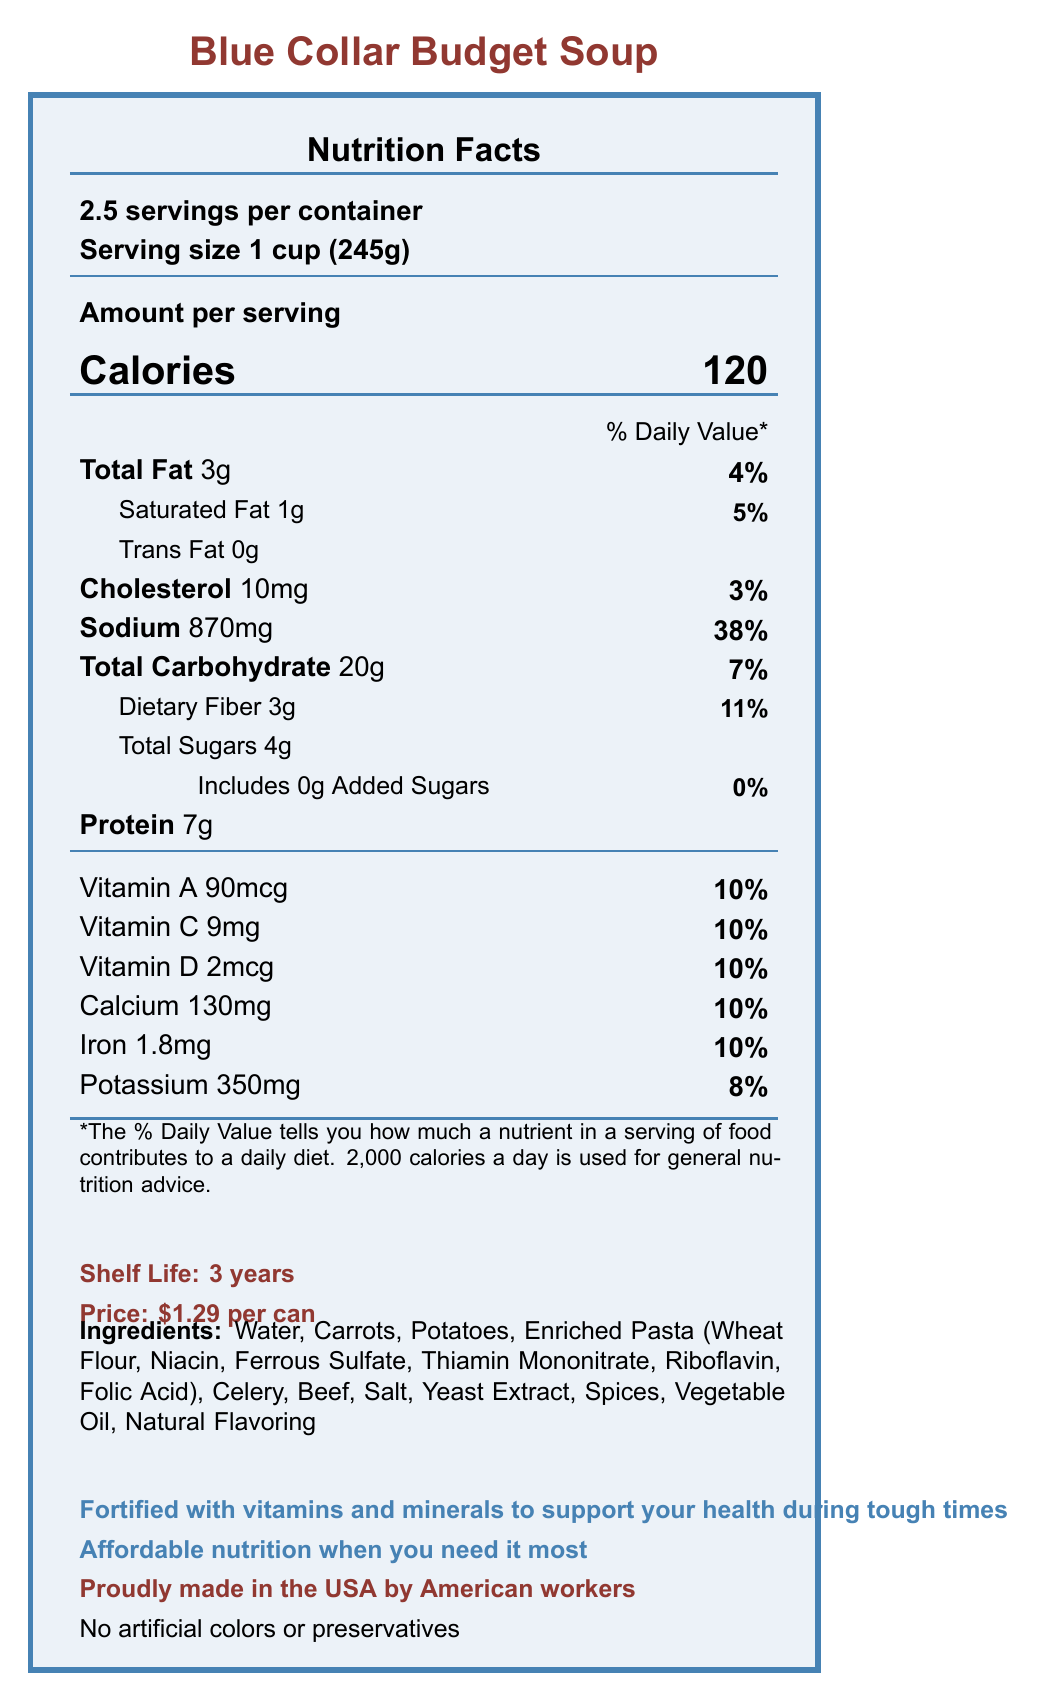what is the serving size of Blue Collar Budget Soup? The serving size is clearly stated as "1 cup (245g)" on the Nutrition Facts Label.
Answer: 1 cup (245g) how many servings are in one container? The document specifies that there are "2.5 servings per container."
Answer: 2.5 servings how many calories are there per serving? It is mentioned that each serving has "120 calories."
Answer: 120 what is the total fat percentage of the daily value per serving? The total fat amount is 3g, which is 4% of the daily value.
Answer: 4% what is the sodium content per serving? The sodium content is listed as "870mg" per serving.
Answer: 870mg how many grams of protein are there in one serving? The document states that there are "7g" of protein per serving.
Answer: 7g how much vitamin A is there per serving? The amount of vitamin A per serving is 90mcg, which is 10% of the daily value.
Answer: 90mcg (10% Daily Value) which ingredient is listed first in the ingredients section? The ingredients list starts with "Water."
Answer: Water what is the shelf life of the product? The shelf life is specified to be "3 years."
Answer: 3 years how much does one can cost? The price is mentioned as "$1.29 per can."
Answer: $1.29 per can how much saturated fat does each serving of soup contain? Each serving contains "1g" of saturated fat.
Answer: 1g what percentage of the daily value of calcium is in one serving? The calcium content per serving is 130mg, which is 10% of the daily value.
Answer: 10% does the soup contain any artificial colors or preservatives? The document states, "No artificial colors or preservatives."
Answer: No which vitamin amount is higher per serving, Vitamin C or Iron? Both Vitamin C and Iron are at 10% Daily Value, but the iron amount in mg is higher.
Answer: Iron how is the protein content compared to the dietary fiber content? A. Higher B. Lower C. Equal The protein content per serving is 7g, which is higher than the dietary fiber content of 3g.
Answer: A how much dietary fiber does the soup have in each serving? A. 1g B. 3g C. 7g D. 20g The dietary fiber content per serving is "3g."
Answer: B what is the main ingredient after water? A. Carrots B. Potatoes C. Enriched Pasta D. Beef The main ingredient after water is "Carrots."
Answer: A is the soup proudly made in the USA by American workers? The document states, "Proudly made in the USA by American workers."
Answer: Yes Summarize the key features of Blue Collar Budget Soup based on the document. This summary captures the document's main points, focusing on nutrition, price, shelf life, and additional claims about the product's quality and origin.
Answer: The Blue Collar Budget Soup is an affordable canned soup, priced at $1.29 per can, with a serving size of 1 cup (245g). There are 2.5 servings per container, with each serving containing 120 calories, 3g of total fat, 870mg of sodium, 20g of carbohydrate, 7g of protein and various vitamins and minerals. The soup is fortified, has no artificial colors or preservatives, has a shelf life of 3 years, and is made in the USA. what is the primary source of protein in the soup? The document does not specify which ingredient is the primary source of protein.
Answer: Cannot be determined 